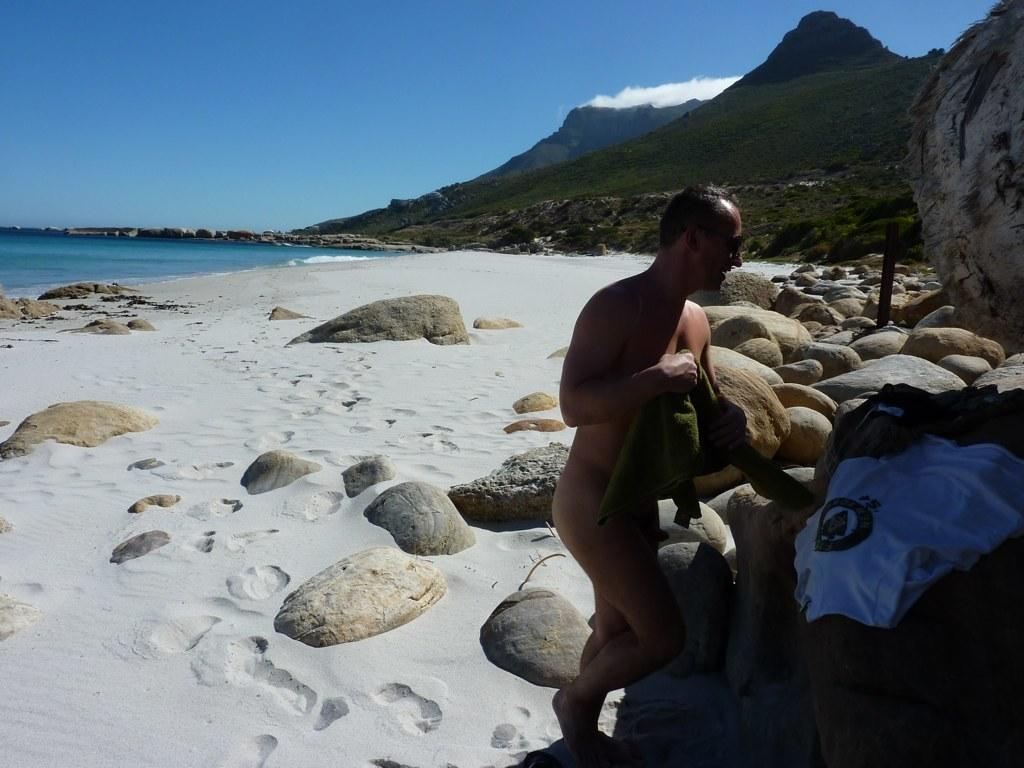Who is present in the image? There is a man in the image. What is the man holding in his hand? The man is holding something in his hand, but the specific object cannot be determined from the facts provided. What type of terrain is visible in the image? There are rocks and sand visible in the image. What can be seen in the background of the image? There is water, hills, and the sky visible in the background. What type of tub is visible in the image? There is no tub present in the image. How many bags of popcorn can be seen in the image? There is no popcorn present in the image. 